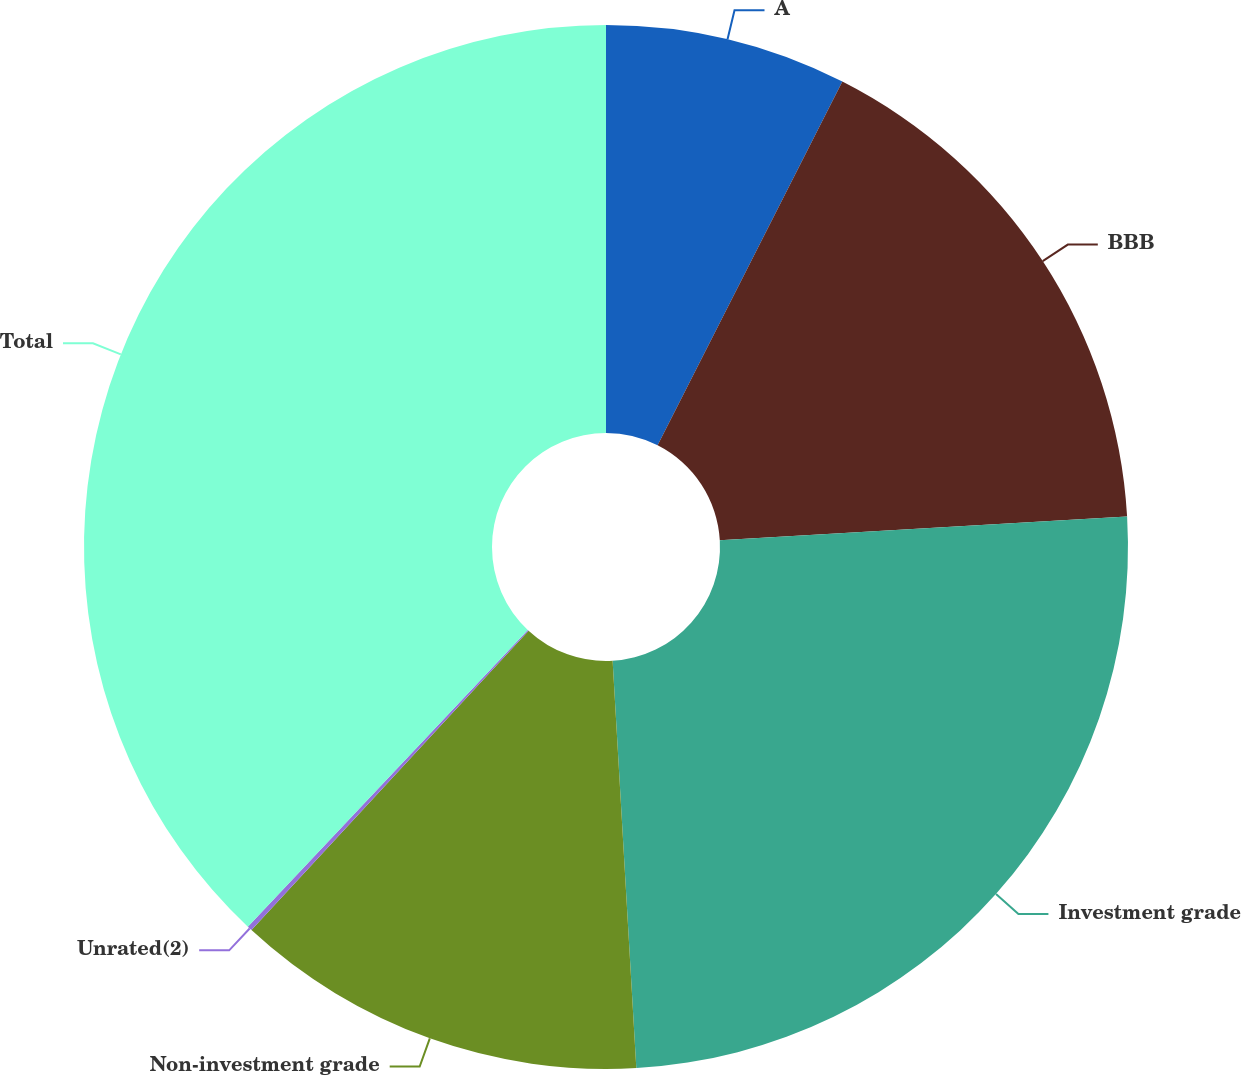Convert chart to OTSL. <chart><loc_0><loc_0><loc_500><loc_500><pie_chart><fcel>A<fcel>BBB<fcel>Investment grade<fcel>Non-investment grade<fcel>Unrated(2)<fcel>Total<nl><fcel>7.48%<fcel>16.59%<fcel>25.01%<fcel>12.81%<fcel>0.15%<fcel>37.97%<nl></chart> 